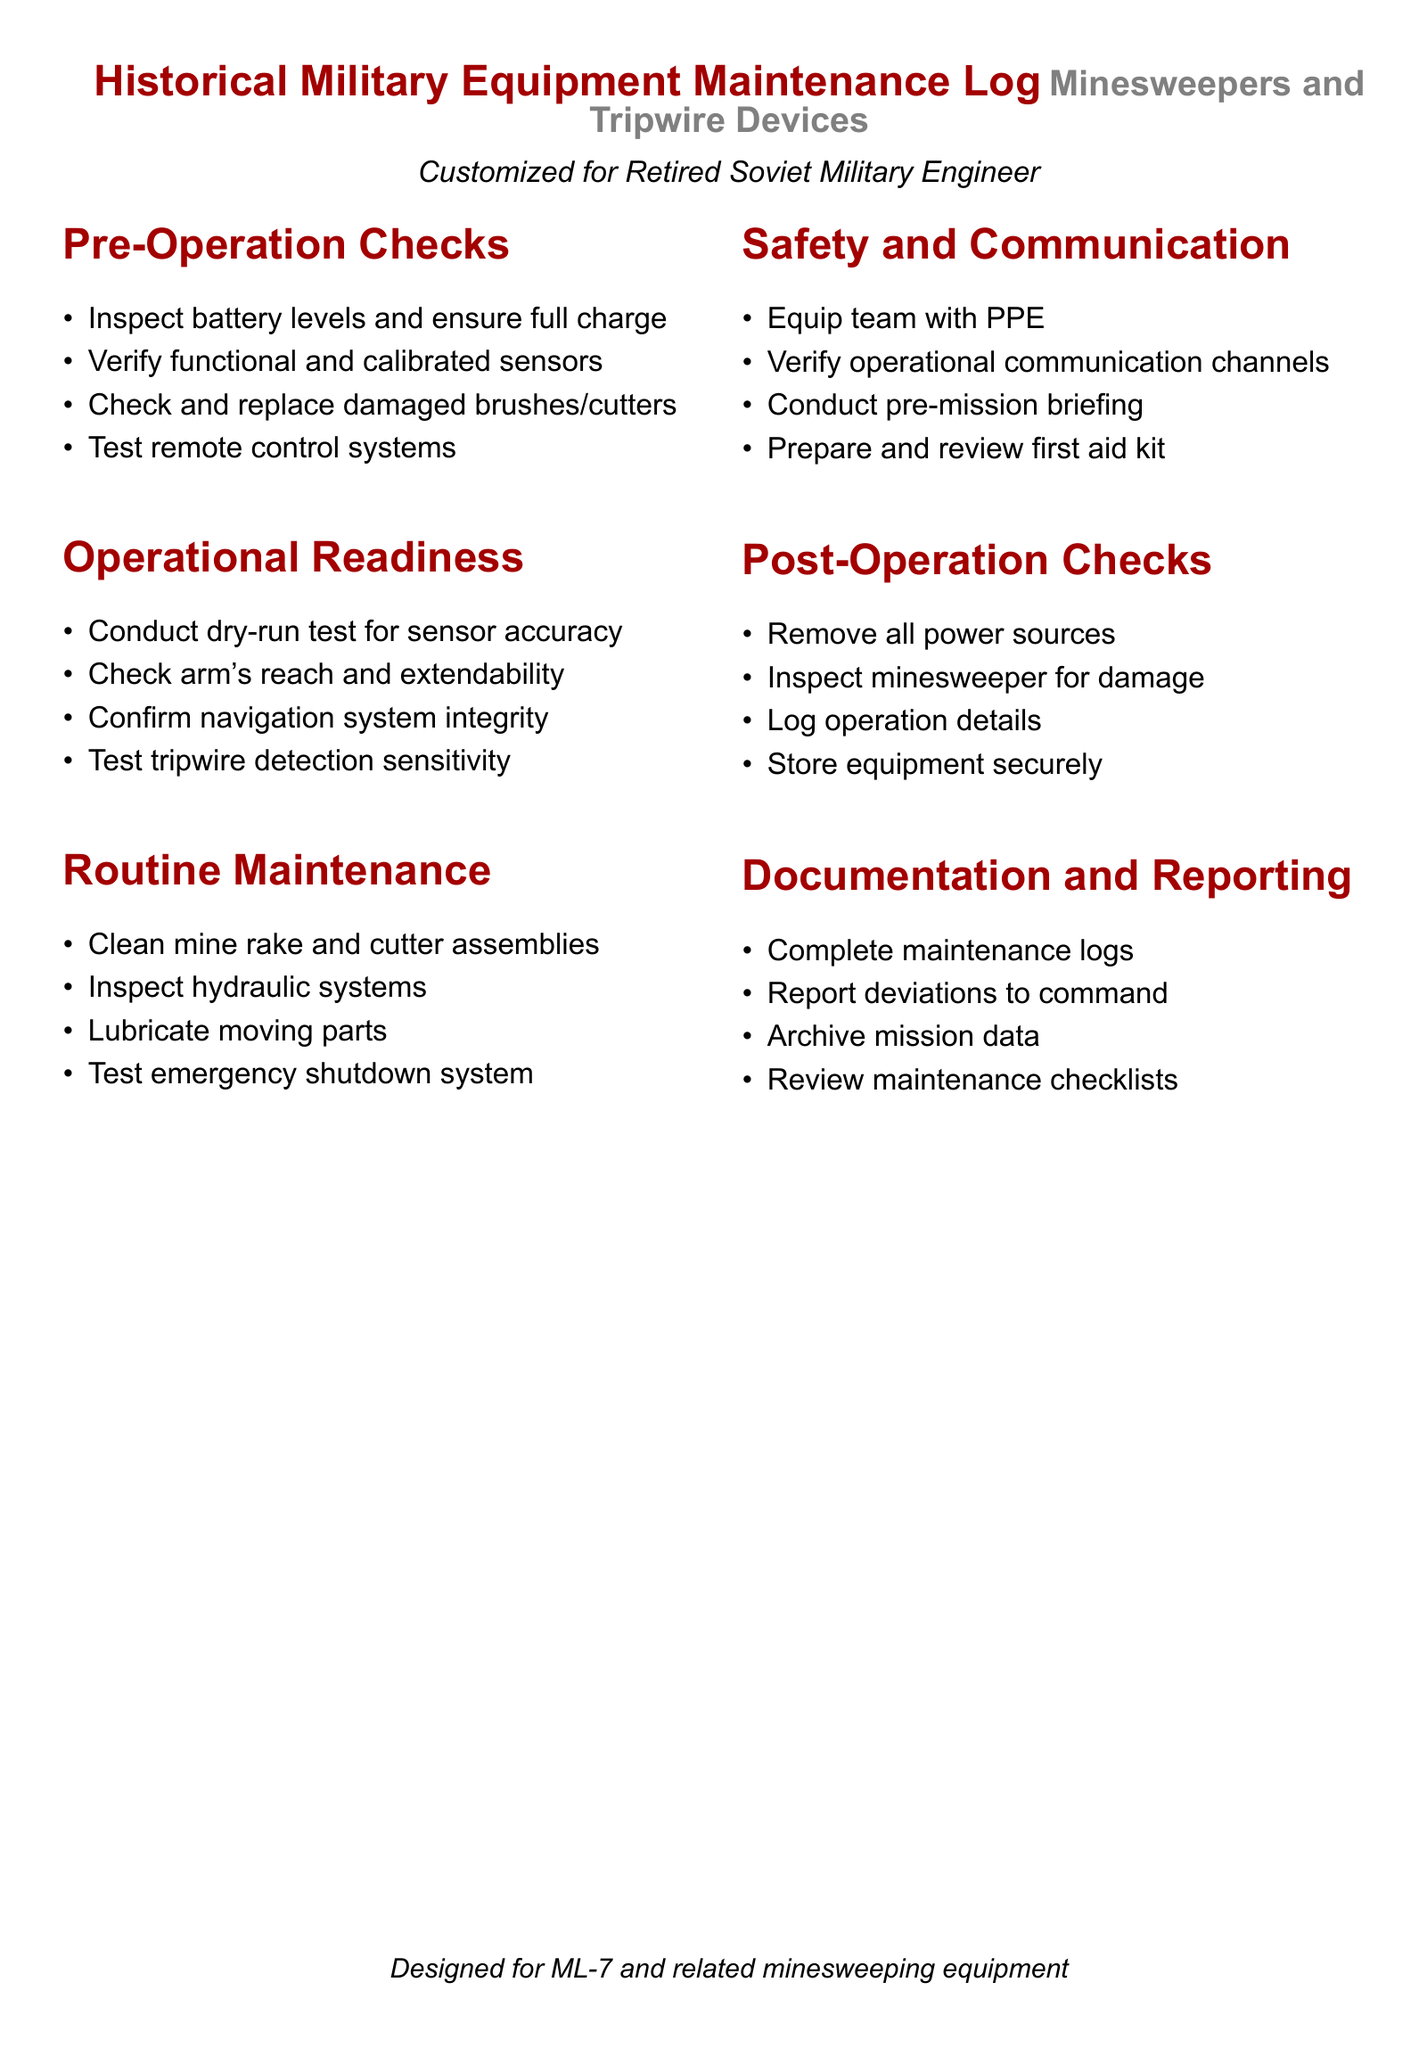what is the title of the document? The title of the document is clearly stated at the beginning, highlighting it in a larger font.
Answer: Historical Military Equipment Maintenance Log who is the document customized for? The document specifies that it is tailored for a specific individual, indicating who the primary audience is.
Answer: Retired Soviet Military Engineer how many sections are there in the checklist? The document lists several key categories necessary for maintenance, and the number of sections can be counted directly from the content.
Answer: Six what should be inspected during the pre-operation checks? The document contains a list of items to verify before operation, specifically outlining the tasks to ensure readiness.
Answer: Battery levels what is the main purpose of the "Post-Operation Checks" section? This section describes the actions to take after an operation, emphasizing the importance of evaluation.
Answer: Inspect minesweeper for damage which equipment related to mines is noted at the end of the document? The conclusion of the document references specific machinery that the checklist is aimed at supporting.
Answer: ML-7 